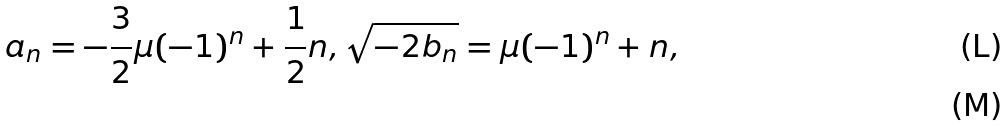Convert formula to latex. <formula><loc_0><loc_0><loc_500><loc_500>a _ { n } = - \frac { 3 } { 2 } \mu ( - 1 ) ^ { n } + \frac { 1 } { 2 } n , \sqrt { - 2 b _ { n } } = \mu ( - 1 ) ^ { n } + n , \\</formula> 